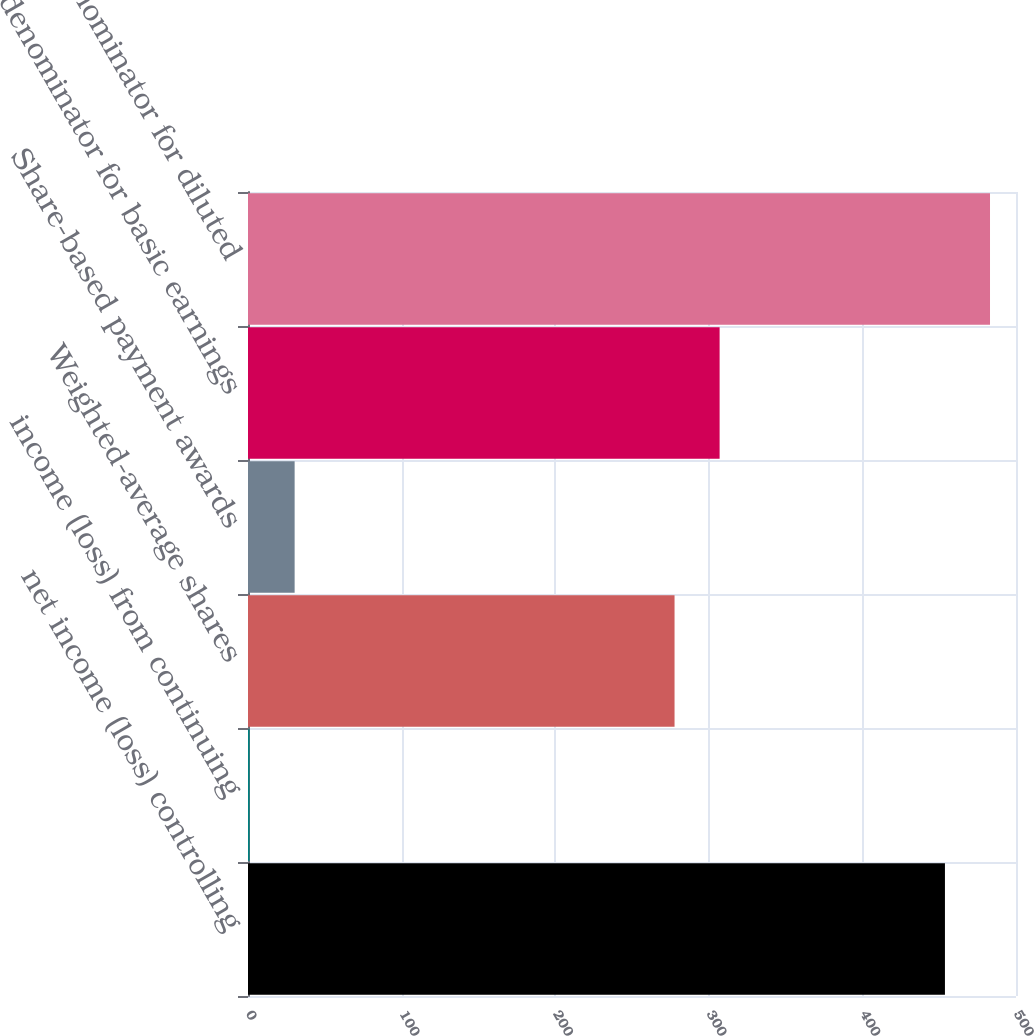Convert chart. <chart><loc_0><loc_0><loc_500><loc_500><bar_chart><fcel>net income (loss) controlling<fcel>income (loss) from continuing<fcel>Weighted-average shares<fcel>Share-based payment awards<fcel>denominator for basic earnings<fcel>denominator for diluted<nl><fcel>453.74<fcel>1.02<fcel>277.7<fcel>30.36<fcel>307.04<fcel>483.08<nl></chart> 